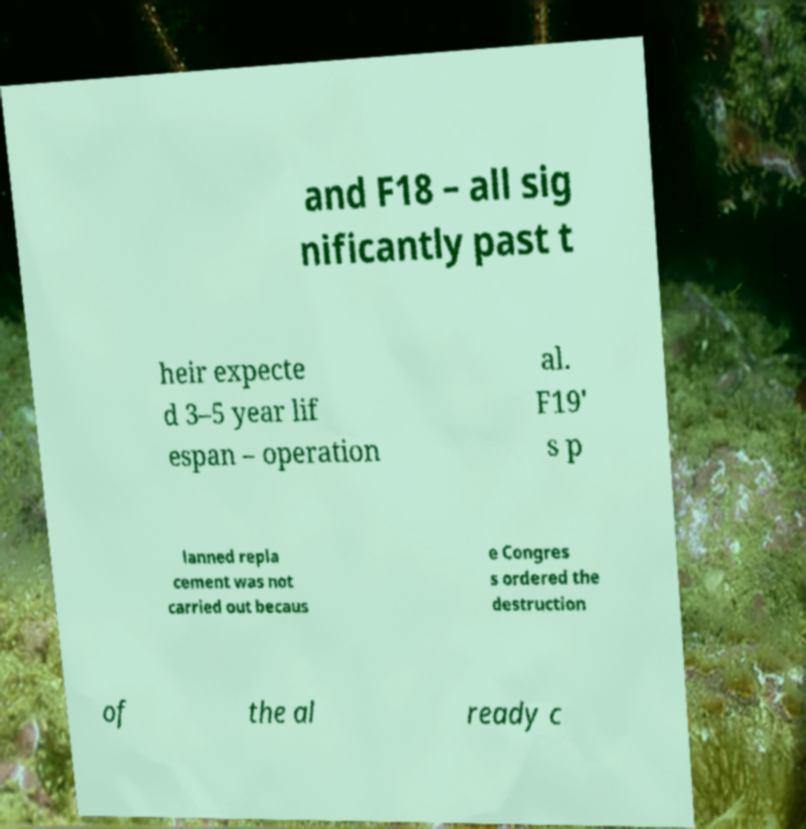Please identify and transcribe the text found in this image. and F18 – all sig nificantly past t heir expecte d 3–5 year lif espan – operation al. F19' s p lanned repla cement was not carried out becaus e Congres s ordered the destruction of the al ready c 